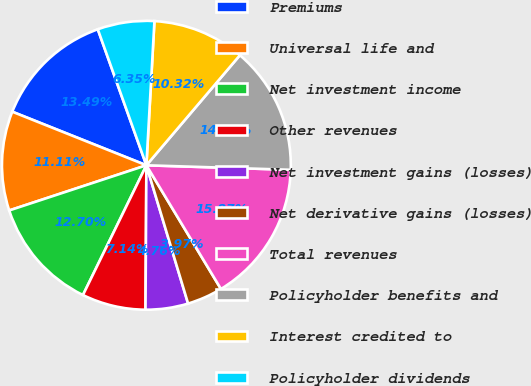Convert chart. <chart><loc_0><loc_0><loc_500><loc_500><pie_chart><fcel>Premiums<fcel>Universal life and<fcel>Net investment income<fcel>Other revenues<fcel>Net investment gains (losses)<fcel>Net derivative gains (losses)<fcel>Total revenues<fcel>Policyholder benefits and<fcel>Interest credited to<fcel>Policyholder dividends<nl><fcel>13.49%<fcel>11.11%<fcel>12.7%<fcel>7.14%<fcel>4.76%<fcel>3.97%<fcel>15.87%<fcel>14.29%<fcel>10.32%<fcel>6.35%<nl></chart> 